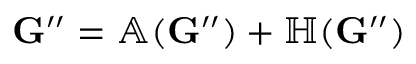Convert formula to latex. <formula><loc_0><loc_0><loc_500><loc_500>G ^ { \prime \prime } = \mathbb { A } ( G ^ { \prime \prime } ) + \mathbb { H } ( G ^ { \prime \prime } )</formula> 